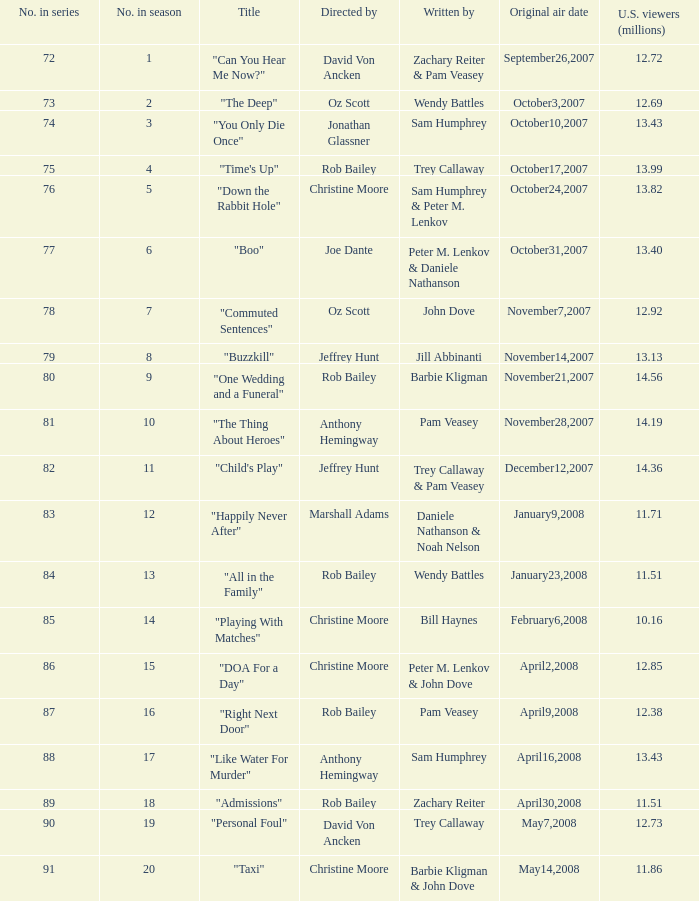How many millions of U.S. viewers watched the episode "Buzzkill"?  1.0. 